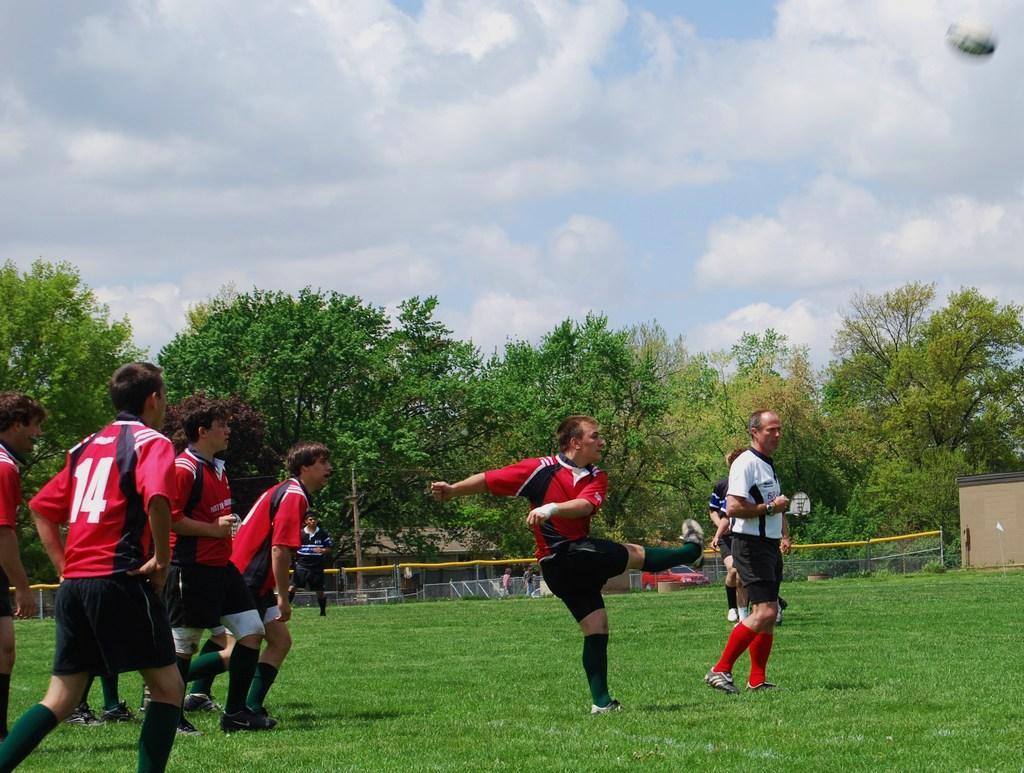Describe this image in one or two sentences. To the left corner of the image there are few men standing with the red t-shirt and black short is standing on the ground. And in the middle of the image there is a man with red t-shirt and black short is standing. In front of him there is a man with white t-shirt and black short is standing on the ground. Behind him in the background there is a fencing and also there are many trees. To the top of the image there is a sky. 